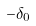<formula> <loc_0><loc_0><loc_500><loc_500>- \delta _ { 0 }</formula> 